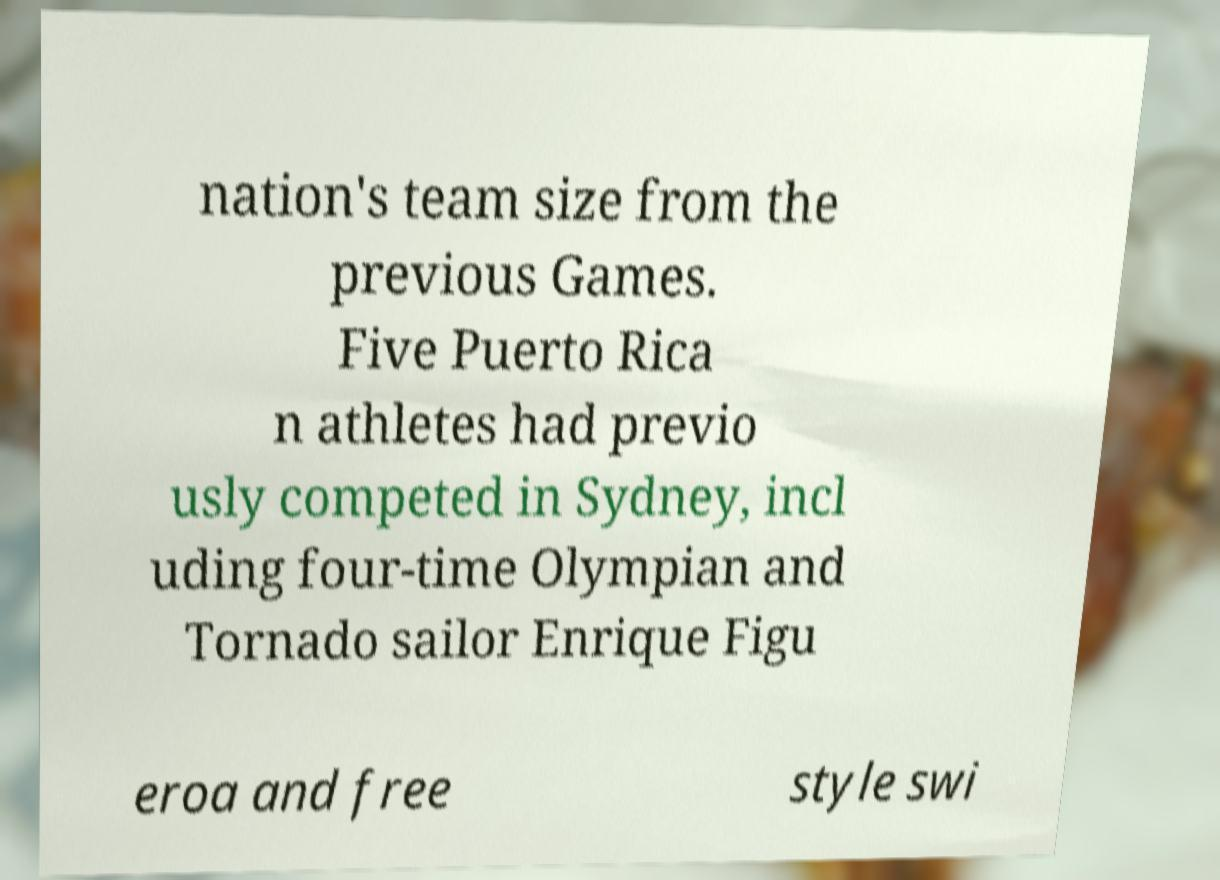There's text embedded in this image that I need extracted. Can you transcribe it verbatim? nation's team size from the previous Games. Five Puerto Rica n athletes had previo usly competed in Sydney, incl uding four-time Olympian and Tornado sailor Enrique Figu eroa and free style swi 